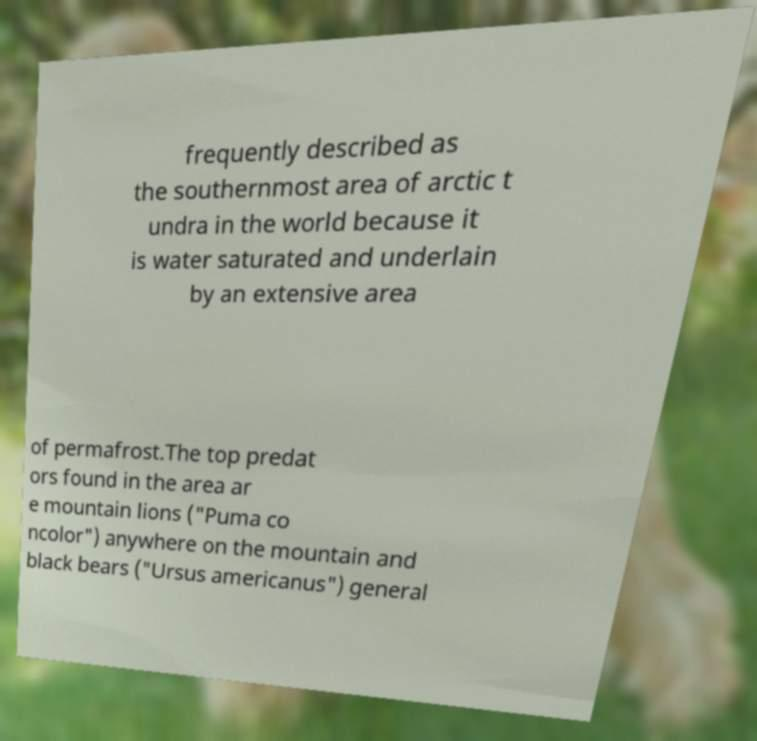There's text embedded in this image that I need extracted. Can you transcribe it verbatim? frequently described as the southernmost area of arctic t undra in the world because it is water saturated and underlain by an extensive area of permafrost.The top predat ors found in the area ar e mountain lions ("Puma co ncolor") anywhere on the mountain and black bears ("Ursus americanus") general 